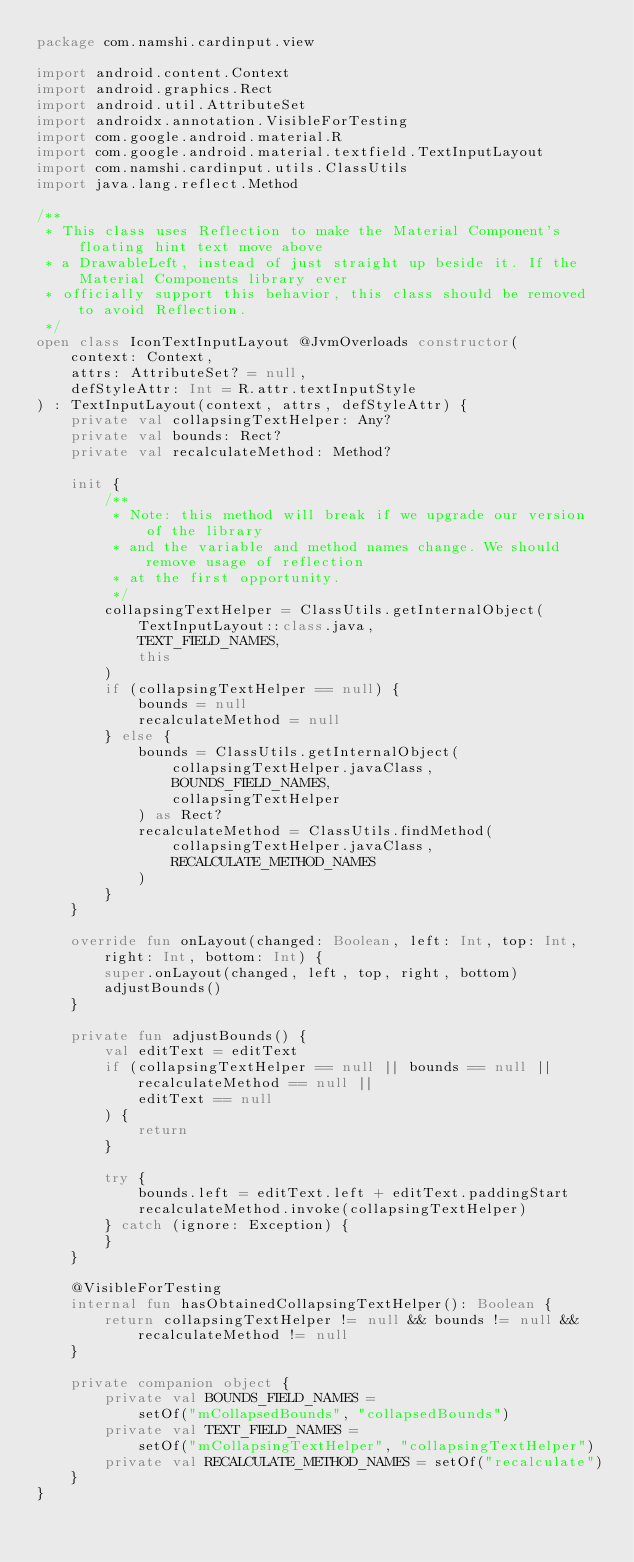Convert code to text. <code><loc_0><loc_0><loc_500><loc_500><_Kotlin_>package com.namshi.cardinput.view

import android.content.Context
import android.graphics.Rect
import android.util.AttributeSet
import androidx.annotation.VisibleForTesting
import com.google.android.material.R
import com.google.android.material.textfield.TextInputLayout
import com.namshi.cardinput.utils.ClassUtils
import java.lang.reflect.Method

/**
 * This class uses Reflection to make the Material Component's floating hint text move above
 * a DrawableLeft, instead of just straight up beside it. If the Material Components library ever
 * officially support this behavior, this class should be removed to avoid Reflection.
 */
open class IconTextInputLayout @JvmOverloads constructor(
    context: Context,
    attrs: AttributeSet? = null,
    defStyleAttr: Int = R.attr.textInputStyle
) : TextInputLayout(context, attrs, defStyleAttr) {
    private val collapsingTextHelper: Any?
    private val bounds: Rect?
    private val recalculateMethod: Method?

    init {
        /**
         * Note: this method will break if we upgrade our version of the library
         * and the variable and method names change. We should remove usage of reflection
         * at the first opportunity.
         */
        collapsingTextHelper = ClassUtils.getInternalObject(
            TextInputLayout::class.java,
            TEXT_FIELD_NAMES,
            this
        )
        if (collapsingTextHelper == null) {
            bounds = null
            recalculateMethod = null
        } else {
            bounds = ClassUtils.getInternalObject(
                collapsingTextHelper.javaClass,
                BOUNDS_FIELD_NAMES,
                collapsingTextHelper
            ) as Rect?
            recalculateMethod = ClassUtils.findMethod(
                collapsingTextHelper.javaClass,
                RECALCULATE_METHOD_NAMES
            )
        }
    }

    override fun onLayout(changed: Boolean, left: Int, top: Int, right: Int, bottom: Int) {
        super.onLayout(changed, left, top, right, bottom)
        adjustBounds()
    }

    private fun adjustBounds() {
        val editText = editText
        if (collapsingTextHelper == null || bounds == null || recalculateMethod == null ||
            editText == null
        ) {
            return
        }

        try {
            bounds.left = editText.left + editText.paddingStart
            recalculateMethod.invoke(collapsingTextHelper)
        } catch (ignore: Exception) {
        }
    }

    @VisibleForTesting
    internal fun hasObtainedCollapsingTextHelper(): Boolean {
        return collapsingTextHelper != null && bounds != null && recalculateMethod != null
    }

    private companion object {
        private val BOUNDS_FIELD_NAMES =
            setOf("mCollapsedBounds", "collapsedBounds")
        private val TEXT_FIELD_NAMES =
            setOf("mCollapsingTextHelper", "collapsingTextHelper")
        private val RECALCULATE_METHOD_NAMES = setOf("recalculate")
    }
}
</code> 